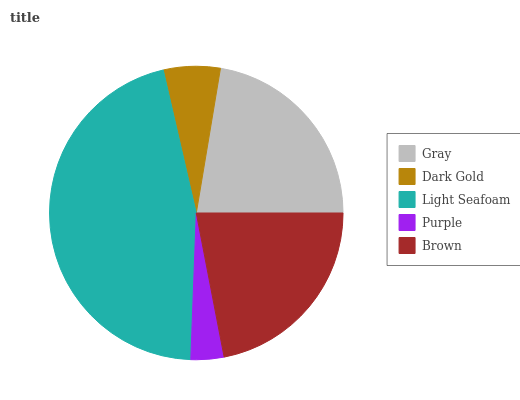Is Purple the minimum?
Answer yes or no. Yes. Is Light Seafoam the maximum?
Answer yes or no. Yes. Is Dark Gold the minimum?
Answer yes or no. No. Is Dark Gold the maximum?
Answer yes or no. No. Is Gray greater than Dark Gold?
Answer yes or no. Yes. Is Dark Gold less than Gray?
Answer yes or no. Yes. Is Dark Gold greater than Gray?
Answer yes or no. No. Is Gray less than Dark Gold?
Answer yes or no. No. Is Brown the high median?
Answer yes or no. Yes. Is Brown the low median?
Answer yes or no. Yes. Is Purple the high median?
Answer yes or no. No. Is Purple the low median?
Answer yes or no. No. 